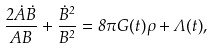Convert formula to latex. <formula><loc_0><loc_0><loc_500><loc_500>\frac { 2 \dot { A } \dot { B } } { A B } + \frac { \dot { B } ^ { 2 } } { B ^ { 2 } } = 8 \pi G ( t ) \rho + \Lambda ( t ) ,</formula> 